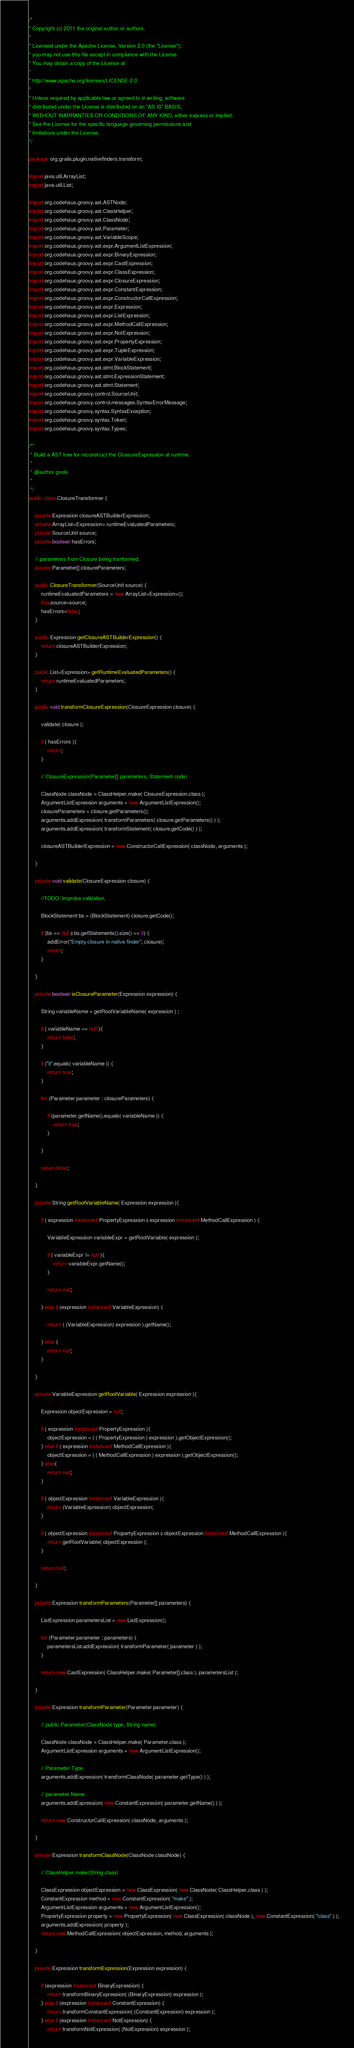<code> <loc_0><loc_0><loc_500><loc_500><_Java_>/*
* Copyright (c) 2011 the original author or authors.
*
* Licensed under the Apache License, Version 2.0 (the "License");
* you may not use this file except in compliance with the License.
* You may obtain a copy of the License at
*
* http://www.apache.org/licenses/LICENSE-2.0
*
* Unless required by applicable law or agreed to in writing, software
* distributed under the License is distributed on an "AS IS" BASIS,
* WITHOUT WARRANTIES OR CONDITIONS OF ANY KIND, either express or implied.
* See the License for the specific language governing permissions and
* limitations under the License.
*/

package org.grails.plugin.nativefinders.transform;

import java.util.ArrayList;
import java.util.List;

import org.codehaus.groovy.ast.ASTNode;
import org.codehaus.groovy.ast.ClassHelper;
import org.codehaus.groovy.ast.ClassNode;
import org.codehaus.groovy.ast.Parameter;
import org.codehaus.groovy.ast.VariableScope;
import org.codehaus.groovy.ast.expr.ArgumentListExpression;
import org.codehaus.groovy.ast.expr.BinaryExpression;
import org.codehaus.groovy.ast.expr.CastExpression;
import org.codehaus.groovy.ast.expr.ClassExpression;
import org.codehaus.groovy.ast.expr.ClosureExpression;
import org.codehaus.groovy.ast.expr.ConstantExpression;
import org.codehaus.groovy.ast.expr.ConstructorCallExpression;
import org.codehaus.groovy.ast.expr.Expression;
import org.codehaus.groovy.ast.expr.ListExpression;
import org.codehaus.groovy.ast.expr.MethodCallExpression;
import org.codehaus.groovy.ast.expr.NotExpression;
import org.codehaus.groovy.ast.expr.PropertyExpression;
import org.codehaus.groovy.ast.expr.TupleExpression;
import org.codehaus.groovy.ast.expr.VariableExpression;
import org.codehaus.groovy.ast.stmt.BlockStatement;
import org.codehaus.groovy.ast.stmt.ExpressionStatement;
import org.codehaus.groovy.ast.stmt.Statement;
import org.codehaus.groovy.control.SourceUnit;
import org.codehaus.groovy.control.messages.SyntaxErrorMessage;
import org.codehaus.groovy.syntax.SyntaxException;
import org.codehaus.groovy.syntax.Token;
import org.codehaus.groovy.syntax.Types;

/**
 * Build a AST tree for reconstruct the ClossureExpression at runtime.
 * 
 * @author gvelo
 * 
 */
public class ClosureTransformer {

	private Expression closureASTBuilderExpression;
	private ArrayList<Expression> runtimeEvaluatedParameters;
	private SourceUnit source;
	private boolean hasErrors;

	// parameters from Closure being tranformed.
	private Parameter[] closureParameters;

	public ClosureTransformer(SourceUnit source) {
		runtimeEvaluatedParameters = new ArrayList<Expression>();
		this.source=source;
		hasErrors=false;		
	}

	public Expression getClosureASTBuilderExpression() {
		return closureASTBuilderExpression;
	}

	public List<Expression> getRuntimeEvaluatedParameters() {
		return runtimeEvaluatedParameters;
	}

	public void transformClosureExpression(ClosureExpression closure) {

		validate( closure );
		
		if ( hasErrors ){
			return;
		}
		
		// ClosureExpression(Parameter[] parameters, Statement code)

		ClassNode classNode = ClassHelper.make( ClosureExpression.class );
		ArgumentListExpression arguments = new ArgumentListExpression();
		closureParameters = closure.getParameters();
		arguments.addExpression( transformParameters( closure.getParameters() ) );
		arguments.addExpression( transformStatement( closure.getCode() ) );

		closureASTBuilderExpression = new ConstructorCallExpression( classNode, arguments );

	}
	
	private void validate(ClosureExpression closure) {

		//TODO: Improbe validation.
		
		BlockStatement bs = (BlockStatement) closure.getCode();

		if (bs == null || bs.getStatements().size() == 0) {
			addError("Empty closure in native finder", closure);
			return;
		}

	}

	private boolean isClosureParameter(Expression expression) {

		String variableName = getRootVariableName( expression ) ;		
		
		if ( variableName == null ){
			return false;
		}

		if ("it".equals( variableName )) {
			return true;
		}

		for (Parameter parameter : closureParameters) {

			if (parameter.getName().equals( variableName )) {
				return true;
			}

		}

		return false;

	}
	
	private String getRootVariableName( Expression expression ){
		
		if ( expression instanceof PropertyExpression || expression instanceof MethodCallExpression ) {
			
			VariableExpression variableExpr = getRootVariable( expression );

			if ( variableExpr != null ){
				return variableExpr.getName();
			}
			
			return null;
			
		} else if (expression instanceof VariableExpression) {

			return ( (VariableExpression) expression ).getName();

		} else {
			return null;
		}
		
	}
	
	private VariableExpression getRootVariable( Expression expression ){
		
		Expression objectExpression = null;
		
		if ( expression instanceof PropertyExpression ){
			objectExpression = ( ( PropertyExpression ) expression ).getObjectExpression();
		} else if ( expression instanceof MethodCallExpression ){
			objectExpression = ( ( MethodCallExpression ) expression ).getObjectExpression();
		} else{
			return null;
		}			
		
		if ( objectExpression instanceof VariableExpression ){
			return (VariableExpression) objectExpression; 
		}
		
		if ( objectExpression instanceof PropertyExpression || objectExpression instanceof MethodCallExpression ){
			return getRootVariable( objectExpression ); 
		}
		
		return null;
		
	}

	private Expression transformParameters(Parameter[] parameters) {

		ListExpression parametersList = new ListExpression();

		for (Parameter parameter : parameters) {
			parametersList.addExpression( transformParameter( parameter ) );
		}

		return new CastExpression( ClassHelper.make( Parameter[].class ), parametersList );

	}

	private Expression transformParameter(Parameter parameter) {

		// public Parameter(ClassNode type, String name)

		ClassNode classNode = ClassHelper.make( Parameter.class );
		ArgumentListExpression arguments = new ArgumentListExpression();

		// Parameter Type
		arguments.addExpression( transformClassNode( parameter.getType() ) );

		// parameter Name
		arguments.addExpression( new ConstantExpression( parameter.getName() ) );

		return new ConstructorCallExpression( classNode, arguments );

	}

	private Expression transformClassNode(ClassNode classNode) {

		// ClassHelper.make(String.class)

		ClassExpression objectExpression = new ClassExpression( new ClassNode( ClassHelper.class ) );
		ConstantExpression method = new ConstantExpression( "make" );
		ArgumentListExpression arguments = new ArgumentListExpression();
		PropertyExpression property = new PropertyExpression( new ClassExpression( classNode ), new ConstantExpression( "class" ) );
		arguments.addExpression( property );
		return new MethodCallExpression( objectExpression, method, arguments );

	}

	private Expression transformExpression(Expression expression) {		

		if (expression instanceof BinaryExpression) {
			return transformBinaryExpression( (BinaryExpression) expression );
		} else if (expression instanceof ConstantExpression) {
			return transformConstantExpression( (ConstantExpression) expression );
		} else if (expression instanceof NotExpression) {
			return transformNotExpression( (NotExpression) expression );</code> 